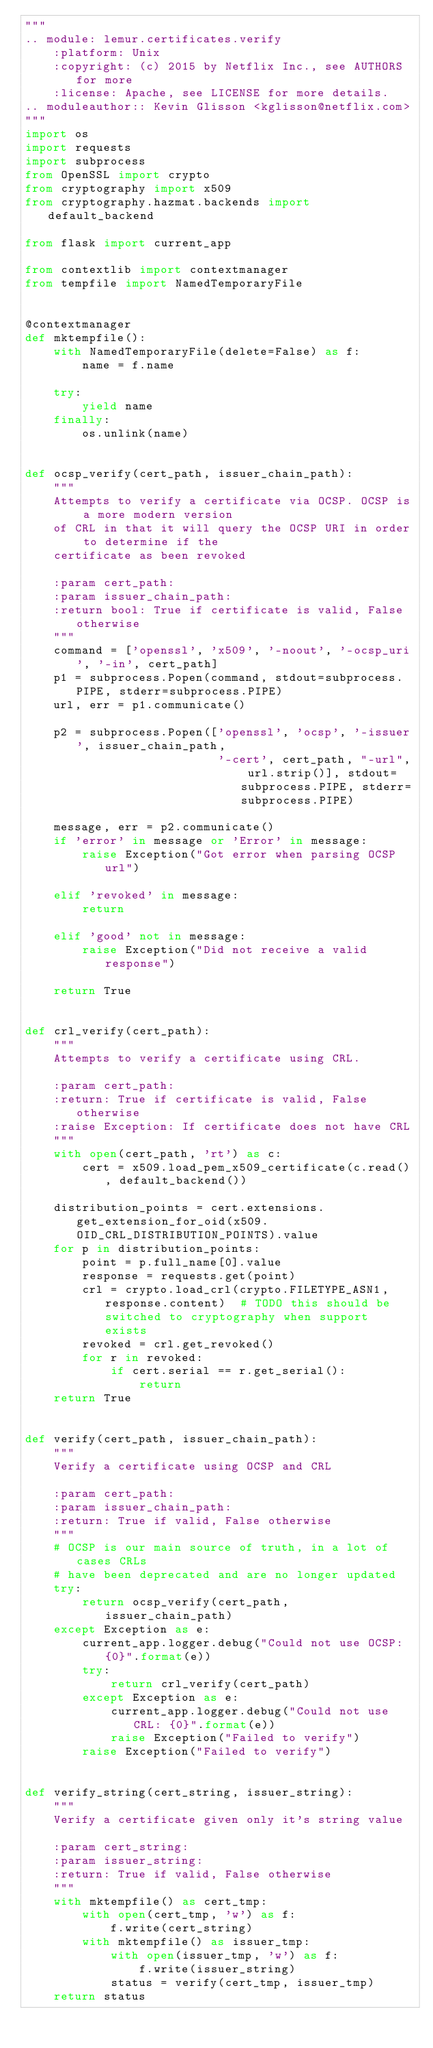Convert code to text. <code><loc_0><loc_0><loc_500><loc_500><_Python_>"""
.. module: lemur.certificates.verify
    :platform: Unix
    :copyright: (c) 2015 by Netflix Inc., see AUTHORS for more
    :license: Apache, see LICENSE for more details.
.. moduleauthor:: Kevin Glisson <kglisson@netflix.com>
"""
import os
import requests
import subprocess
from OpenSSL import crypto
from cryptography import x509
from cryptography.hazmat.backends import default_backend

from flask import current_app

from contextlib import contextmanager
from tempfile import NamedTemporaryFile


@contextmanager
def mktempfile():
    with NamedTemporaryFile(delete=False) as f:
        name = f.name

    try:
        yield name
    finally:
        os.unlink(name)


def ocsp_verify(cert_path, issuer_chain_path):
    """
    Attempts to verify a certificate via OCSP. OCSP is a more modern version
    of CRL in that it will query the OCSP URI in order to determine if the
    certificate as been revoked

    :param cert_path:
    :param issuer_chain_path:
    :return bool: True if certificate is valid, False otherwise
    """
    command = ['openssl', 'x509', '-noout', '-ocsp_uri', '-in', cert_path]
    p1 = subprocess.Popen(command, stdout=subprocess.PIPE, stderr=subprocess.PIPE)
    url, err = p1.communicate()

    p2 = subprocess.Popen(['openssl', 'ocsp', '-issuer', issuer_chain_path,
                           '-cert', cert_path, "-url", url.strip()], stdout=subprocess.PIPE, stderr=subprocess.PIPE)

    message, err = p2.communicate()
    if 'error' in message or 'Error' in message:
        raise Exception("Got error when parsing OCSP url")

    elif 'revoked' in message:
        return

    elif 'good' not in message:
        raise Exception("Did not receive a valid response")

    return True


def crl_verify(cert_path):
    """
    Attempts to verify a certificate using CRL.

    :param cert_path:
    :return: True if certificate is valid, False otherwise
    :raise Exception: If certificate does not have CRL
    """
    with open(cert_path, 'rt') as c:
        cert = x509.load_pem_x509_certificate(c.read(), default_backend())

    distribution_points = cert.extensions.get_extension_for_oid(x509.OID_CRL_DISTRIBUTION_POINTS).value
    for p in distribution_points:
        point = p.full_name[0].value
        response = requests.get(point)
        crl = crypto.load_crl(crypto.FILETYPE_ASN1, response.content)  # TODO this should be switched to cryptography when support exists
        revoked = crl.get_revoked()
        for r in revoked:
            if cert.serial == r.get_serial():
                return
    return True


def verify(cert_path, issuer_chain_path):
    """
    Verify a certificate using OCSP and CRL

    :param cert_path:
    :param issuer_chain_path:
    :return: True if valid, False otherwise
    """
    # OCSP is our main source of truth, in a lot of cases CRLs
    # have been deprecated and are no longer updated
    try:
        return ocsp_verify(cert_path, issuer_chain_path)
    except Exception as e:
        current_app.logger.debug("Could not use OCSP: {0}".format(e))
        try:
            return crl_verify(cert_path)
        except Exception as e:
            current_app.logger.debug("Could not use CRL: {0}".format(e))
            raise Exception("Failed to verify")
        raise Exception("Failed to verify")


def verify_string(cert_string, issuer_string):
    """
    Verify a certificate given only it's string value

    :param cert_string:
    :param issuer_string:
    :return: True if valid, False otherwise
    """
    with mktempfile() as cert_tmp:
        with open(cert_tmp, 'w') as f:
            f.write(cert_string)
        with mktempfile() as issuer_tmp:
            with open(issuer_tmp, 'w') as f:
                f.write(issuer_string)
            status = verify(cert_tmp, issuer_tmp)
    return status
</code> 